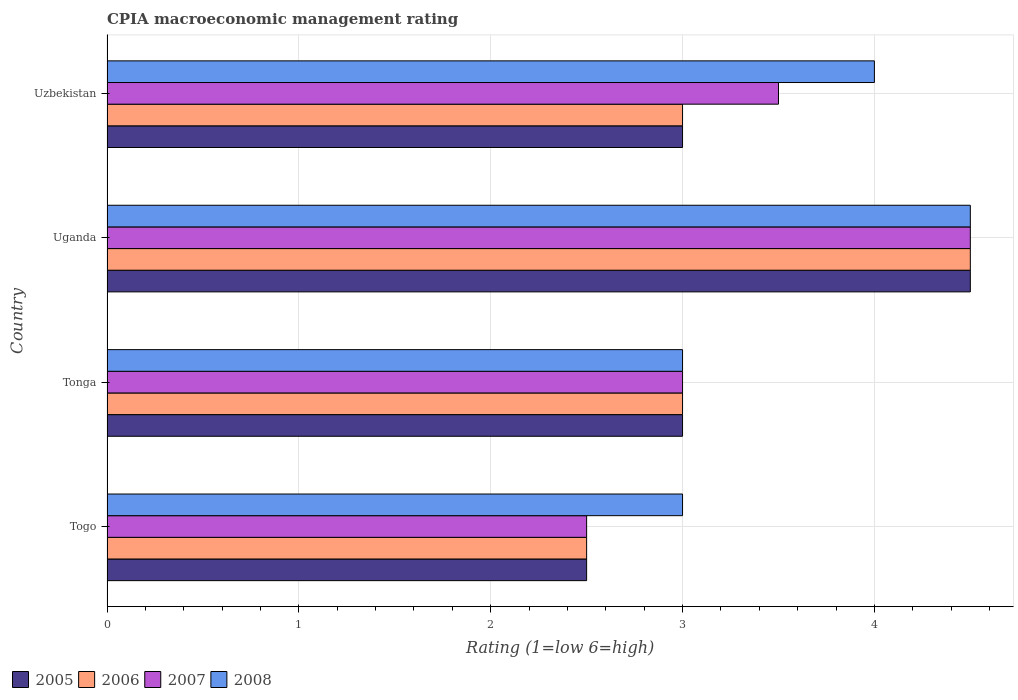How many groups of bars are there?
Make the answer very short. 4. How many bars are there on the 3rd tick from the bottom?
Keep it short and to the point. 4. What is the label of the 2nd group of bars from the top?
Give a very brief answer. Uganda. In how many cases, is the number of bars for a given country not equal to the number of legend labels?
Your answer should be compact. 0. What is the CPIA rating in 2008 in Togo?
Make the answer very short. 3. Across all countries, what is the maximum CPIA rating in 2007?
Provide a short and direct response. 4.5. Across all countries, what is the minimum CPIA rating in 2006?
Provide a short and direct response. 2.5. In which country was the CPIA rating in 2006 maximum?
Make the answer very short. Uganda. In which country was the CPIA rating in 2008 minimum?
Your answer should be very brief. Togo. What is the difference between the CPIA rating in 2006 in Tonga and that in Uganda?
Make the answer very short. -1.5. In how many countries, is the CPIA rating in 2005 greater than 1.2 ?
Your response must be concise. 4. What is the ratio of the CPIA rating in 2007 in Togo to that in Uganda?
Your answer should be very brief. 0.56. Is the CPIA rating in 2005 in Tonga less than that in Uganda?
Offer a very short reply. Yes. What is the difference between the highest and the second highest CPIA rating in 2008?
Make the answer very short. 0.5. What is the difference between the highest and the lowest CPIA rating in 2007?
Keep it short and to the point. 2. In how many countries, is the CPIA rating in 2007 greater than the average CPIA rating in 2007 taken over all countries?
Offer a terse response. 2. Is the sum of the CPIA rating in 2008 in Togo and Tonga greater than the maximum CPIA rating in 2007 across all countries?
Offer a terse response. Yes. Is it the case that in every country, the sum of the CPIA rating in 2008 and CPIA rating in 2006 is greater than the sum of CPIA rating in 2005 and CPIA rating in 2007?
Offer a very short reply. No. What does the 2nd bar from the top in Tonga represents?
Your answer should be very brief. 2007. How many bars are there?
Provide a succinct answer. 16. What is the difference between two consecutive major ticks on the X-axis?
Your response must be concise. 1. Are the values on the major ticks of X-axis written in scientific E-notation?
Offer a terse response. No. Does the graph contain any zero values?
Your answer should be compact. No. Does the graph contain grids?
Offer a terse response. Yes. Where does the legend appear in the graph?
Your answer should be very brief. Bottom left. How many legend labels are there?
Offer a terse response. 4. What is the title of the graph?
Give a very brief answer. CPIA macroeconomic management rating. What is the label or title of the Y-axis?
Ensure brevity in your answer.  Country. What is the Rating (1=low 6=high) of 2005 in Togo?
Offer a very short reply. 2.5. What is the Rating (1=low 6=high) in 2007 in Togo?
Make the answer very short. 2.5. What is the Rating (1=low 6=high) of 2005 in Tonga?
Give a very brief answer. 3. What is the Rating (1=low 6=high) of 2007 in Tonga?
Offer a terse response. 3. What is the Rating (1=low 6=high) of 2006 in Uganda?
Give a very brief answer. 4.5. What is the Rating (1=low 6=high) in 2006 in Uzbekistan?
Offer a very short reply. 3. What is the Rating (1=low 6=high) of 2007 in Uzbekistan?
Make the answer very short. 3.5. Across all countries, what is the maximum Rating (1=low 6=high) in 2005?
Offer a very short reply. 4.5. Across all countries, what is the maximum Rating (1=low 6=high) of 2007?
Ensure brevity in your answer.  4.5. Across all countries, what is the minimum Rating (1=low 6=high) of 2005?
Your answer should be compact. 2.5. Across all countries, what is the minimum Rating (1=low 6=high) in 2007?
Make the answer very short. 2.5. What is the total Rating (1=low 6=high) in 2006 in the graph?
Provide a succinct answer. 13. What is the difference between the Rating (1=low 6=high) in 2005 in Togo and that in Tonga?
Provide a succinct answer. -0.5. What is the difference between the Rating (1=low 6=high) in 2006 in Togo and that in Tonga?
Provide a succinct answer. -0.5. What is the difference between the Rating (1=low 6=high) in 2008 in Togo and that in Tonga?
Your response must be concise. 0. What is the difference between the Rating (1=low 6=high) of 2005 in Togo and that in Uganda?
Provide a short and direct response. -2. What is the difference between the Rating (1=low 6=high) of 2006 in Togo and that in Uganda?
Give a very brief answer. -2. What is the difference between the Rating (1=low 6=high) of 2007 in Togo and that in Uganda?
Make the answer very short. -2. What is the difference between the Rating (1=low 6=high) in 2006 in Togo and that in Uzbekistan?
Keep it short and to the point. -0.5. What is the difference between the Rating (1=low 6=high) in 2007 in Togo and that in Uzbekistan?
Offer a very short reply. -1. What is the difference between the Rating (1=low 6=high) of 2008 in Togo and that in Uzbekistan?
Your response must be concise. -1. What is the difference between the Rating (1=low 6=high) of 2005 in Tonga and that in Uzbekistan?
Your response must be concise. 0. What is the difference between the Rating (1=low 6=high) in 2008 in Tonga and that in Uzbekistan?
Provide a succinct answer. -1. What is the difference between the Rating (1=low 6=high) in 2007 in Uganda and that in Uzbekistan?
Your answer should be very brief. 1. What is the difference between the Rating (1=low 6=high) of 2008 in Uganda and that in Uzbekistan?
Make the answer very short. 0.5. What is the difference between the Rating (1=low 6=high) of 2005 in Togo and the Rating (1=low 6=high) of 2007 in Tonga?
Ensure brevity in your answer.  -0.5. What is the difference between the Rating (1=low 6=high) of 2006 in Togo and the Rating (1=low 6=high) of 2007 in Tonga?
Give a very brief answer. -0.5. What is the difference between the Rating (1=low 6=high) in 2007 in Togo and the Rating (1=low 6=high) in 2008 in Tonga?
Give a very brief answer. -0.5. What is the difference between the Rating (1=low 6=high) in 2005 in Togo and the Rating (1=low 6=high) in 2007 in Uganda?
Ensure brevity in your answer.  -2. What is the difference between the Rating (1=low 6=high) of 2005 in Togo and the Rating (1=low 6=high) of 2008 in Uganda?
Your answer should be very brief. -2. What is the difference between the Rating (1=low 6=high) in 2006 in Togo and the Rating (1=low 6=high) in 2007 in Uganda?
Keep it short and to the point. -2. What is the difference between the Rating (1=low 6=high) in 2006 in Togo and the Rating (1=low 6=high) in 2008 in Uganda?
Provide a short and direct response. -2. What is the difference between the Rating (1=low 6=high) in 2005 in Togo and the Rating (1=low 6=high) in 2007 in Uzbekistan?
Make the answer very short. -1. What is the difference between the Rating (1=low 6=high) in 2006 in Togo and the Rating (1=low 6=high) in 2007 in Uzbekistan?
Provide a succinct answer. -1. What is the difference between the Rating (1=low 6=high) in 2005 in Tonga and the Rating (1=low 6=high) in 2006 in Uganda?
Offer a terse response. -1.5. What is the difference between the Rating (1=low 6=high) of 2005 in Tonga and the Rating (1=low 6=high) of 2007 in Uganda?
Provide a short and direct response. -1.5. What is the difference between the Rating (1=low 6=high) of 2006 in Tonga and the Rating (1=low 6=high) of 2007 in Uganda?
Offer a terse response. -1.5. What is the difference between the Rating (1=low 6=high) in 2005 in Tonga and the Rating (1=low 6=high) in 2007 in Uzbekistan?
Keep it short and to the point. -0.5. What is the difference between the Rating (1=low 6=high) of 2005 in Tonga and the Rating (1=low 6=high) of 2008 in Uzbekistan?
Give a very brief answer. -1. What is the difference between the Rating (1=low 6=high) of 2006 in Tonga and the Rating (1=low 6=high) of 2008 in Uzbekistan?
Offer a terse response. -1. What is the difference between the Rating (1=low 6=high) in 2007 in Tonga and the Rating (1=low 6=high) in 2008 in Uzbekistan?
Your answer should be compact. -1. What is the difference between the Rating (1=low 6=high) in 2005 in Uganda and the Rating (1=low 6=high) in 2006 in Uzbekistan?
Ensure brevity in your answer.  1.5. What is the difference between the Rating (1=low 6=high) in 2005 in Uganda and the Rating (1=low 6=high) in 2008 in Uzbekistan?
Your answer should be very brief. 0.5. What is the difference between the Rating (1=low 6=high) of 2006 in Uganda and the Rating (1=low 6=high) of 2007 in Uzbekistan?
Ensure brevity in your answer.  1. What is the difference between the Rating (1=low 6=high) of 2006 in Uganda and the Rating (1=low 6=high) of 2008 in Uzbekistan?
Provide a succinct answer. 0.5. What is the difference between the Rating (1=low 6=high) in 2007 in Uganda and the Rating (1=low 6=high) in 2008 in Uzbekistan?
Your answer should be very brief. 0.5. What is the average Rating (1=low 6=high) in 2007 per country?
Your response must be concise. 3.38. What is the average Rating (1=low 6=high) in 2008 per country?
Make the answer very short. 3.62. What is the difference between the Rating (1=low 6=high) in 2005 and Rating (1=low 6=high) in 2006 in Togo?
Your answer should be very brief. 0. What is the difference between the Rating (1=low 6=high) of 2006 and Rating (1=low 6=high) of 2007 in Togo?
Make the answer very short. 0. What is the difference between the Rating (1=low 6=high) of 2005 and Rating (1=low 6=high) of 2008 in Tonga?
Your response must be concise. 0. What is the difference between the Rating (1=low 6=high) of 2007 and Rating (1=low 6=high) of 2008 in Tonga?
Offer a very short reply. 0. What is the difference between the Rating (1=low 6=high) of 2005 and Rating (1=low 6=high) of 2007 in Uganda?
Your answer should be compact. 0. What is the difference between the Rating (1=low 6=high) of 2006 and Rating (1=low 6=high) of 2007 in Uganda?
Your answer should be very brief. 0. What is the difference between the Rating (1=low 6=high) in 2006 and Rating (1=low 6=high) in 2008 in Uganda?
Offer a terse response. 0. What is the difference between the Rating (1=low 6=high) of 2005 and Rating (1=low 6=high) of 2007 in Uzbekistan?
Ensure brevity in your answer.  -0.5. What is the difference between the Rating (1=low 6=high) in 2005 and Rating (1=low 6=high) in 2008 in Uzbekistan?
Offer a terse response. -1. What is the ratio of the Rating (1=low 6=high) of 2007 in Togo to that in Tonga?
Your response must be concise. 0.83. What is the ratio of the Rating (1=low 6=high) in 2008 in Togo to that in Tonga?
Your response must be concise. 1. What is the ratio of the Rating (1=low 6=high) in 2005 in Togo to that in Uganda?
Offer a very short reply. 0.56. What is the ratio of the Rating (1=low 6=high) of 2006 in Togo to that in Uganda?
Offer a very short reply. 0.56. What is the ratio of the Rating (1=low 6=high) in 2007 in Togo to that in Uganda?
Provide a short and direct response. 0.56. What is the ratio of the Rating (1=low 6=high) of 2008 in Togo to that in Uganda?
Offer a very short reply. 0.67. What is the ratio of the Rating (1=low 6=high) of 2005 in Togo to that in Uzbekistan?
Offer a very short reply. 0.83. What is the ratio of the Rating (1=low 6=high) in 2006 in Togo to that in Uzbekistan?
Offer a very short reply. 0.83. What is the ratio of the Rating (1=low 6=high) of 2008 in Togo to that in Uzbekistan?
Offer a very short reply. 0.75. What is the ratio of the Rating (1=low 6=high) in 2006 in Tonga to that in Uganda?
Keep it short and to the point. 0.67. What is the ratio of the Rating (1=low 6=high) in 2008 in Tonga to that in Uganda?
Keep it short and to the point. 0.67. What is the ratio of the Rating (1=low 6=high) of 2006 in Tonga to that in Uzbekistan?
Provide a succinct answer. 1. What is the ratio of the Rating (1=low 6=high) of 2008 in Tonga to that in Uzbekistan?
Make the answer very short. 0.75. What is the ratio of the Rating (1=low 6=high) of 2006 in Uganda to that in Uzbekistan?
Keep it short and to the point. 1.5. What is the difference between the highest and the second highest Rating (1=low 6=high) in 2005?
Give a very brief answer. 1.5. What is the difference between the highest and the second highest Rating (1=low 6=high) in 2006?
Offer a very short reply. 1.5. What is the difference between the highest and the second highest Rating (1=low 6=high) in 2007?
Keep it short and to the point. 1. What is the difference between the highest and the second highest Rating (1=low 6=high) in 2008?
Your response must be concise. 0.5. What is the difference between the highest and the lowest Rating (1=low 6=high) of 2008?
Your answer should be very brief. 1.5. 